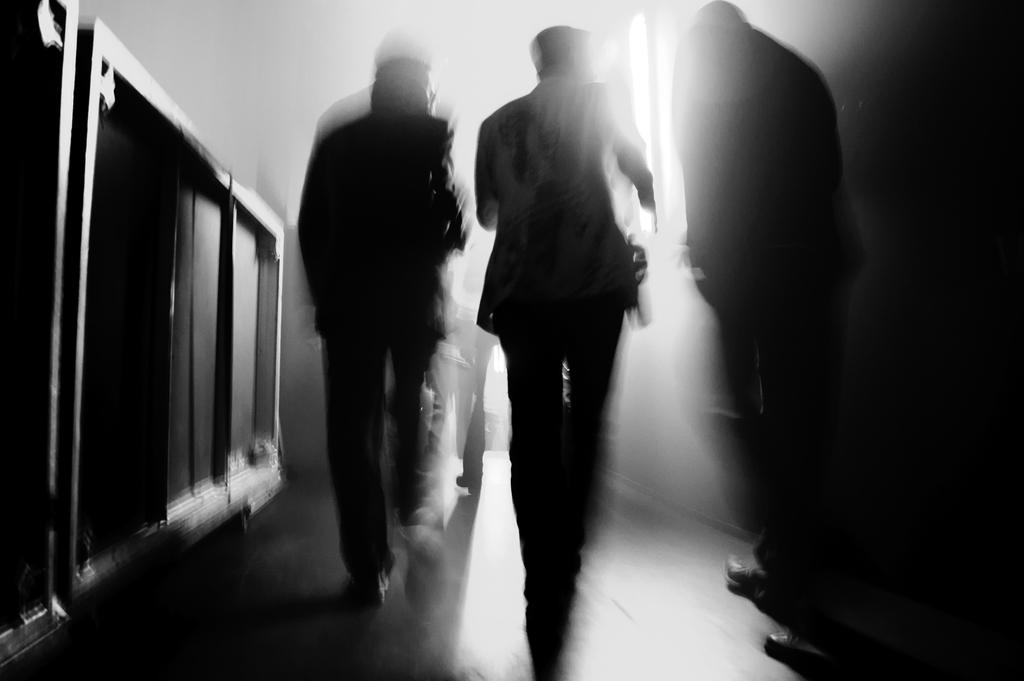What is the color scheme of the image? The image is black and white. What are the persons in the image doing? The persons in the image are walking. On what surface are the persons walking? The persons are walking on the floor. What can be seen in the background of the image? There is a window in the image. What is present on the left side of the image? There is a wooden barrier on the left side of the image. How many bikes are parked in the yard in the image? There is no yard or bike present in the image. What type of waste can be seen in the image? There is no waste present in the image. 